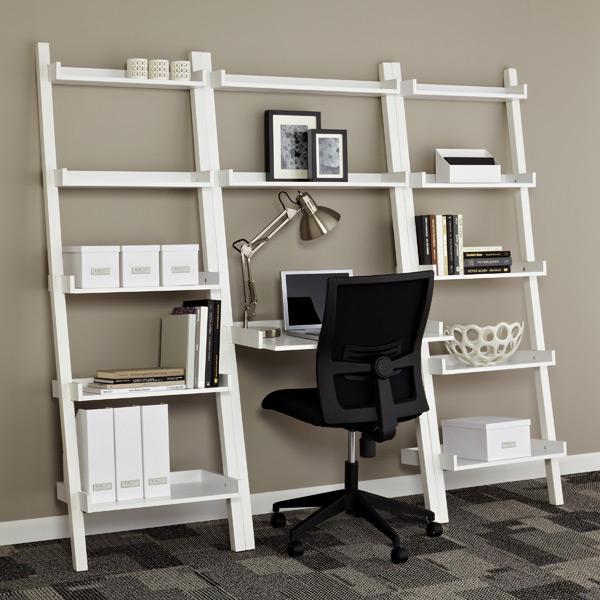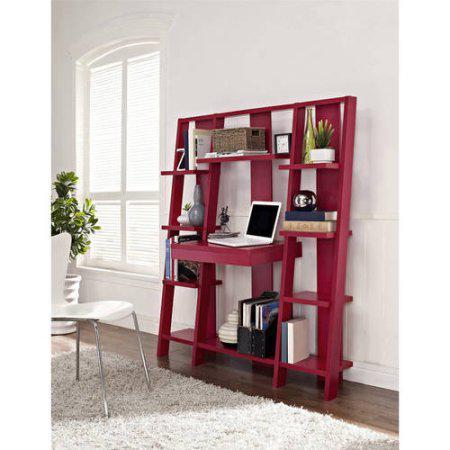The first image is the image on the left, the second image is the image on the right. Examine the images to the left and right. Is the description "The bookshelf on the right is burgundy in color and has a white laptop at its center, and the bookshelf on the left juts from the wall at an angle." accurate? Answer yes or no. Yes. 